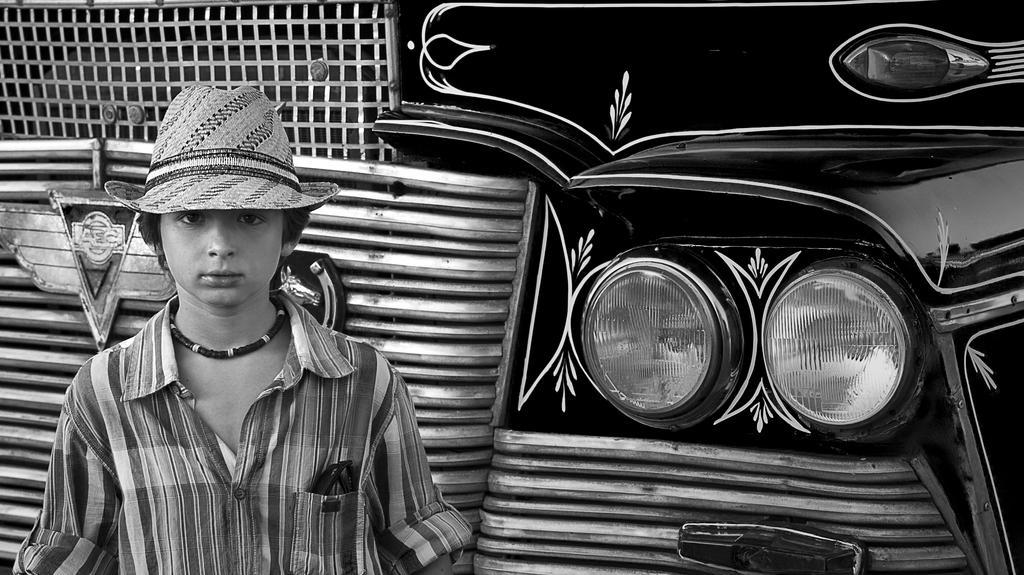Please provide a concise description of this image. In the foreground I can see a boy is wearing a hat and a vehicle. This image is taken may be during a day. 